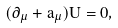<formula> <loc_0><loc_0><loc_500><loc_500>( \partial _ { \mu } + a _ { \mu } ) U = 0 ,</formula> 